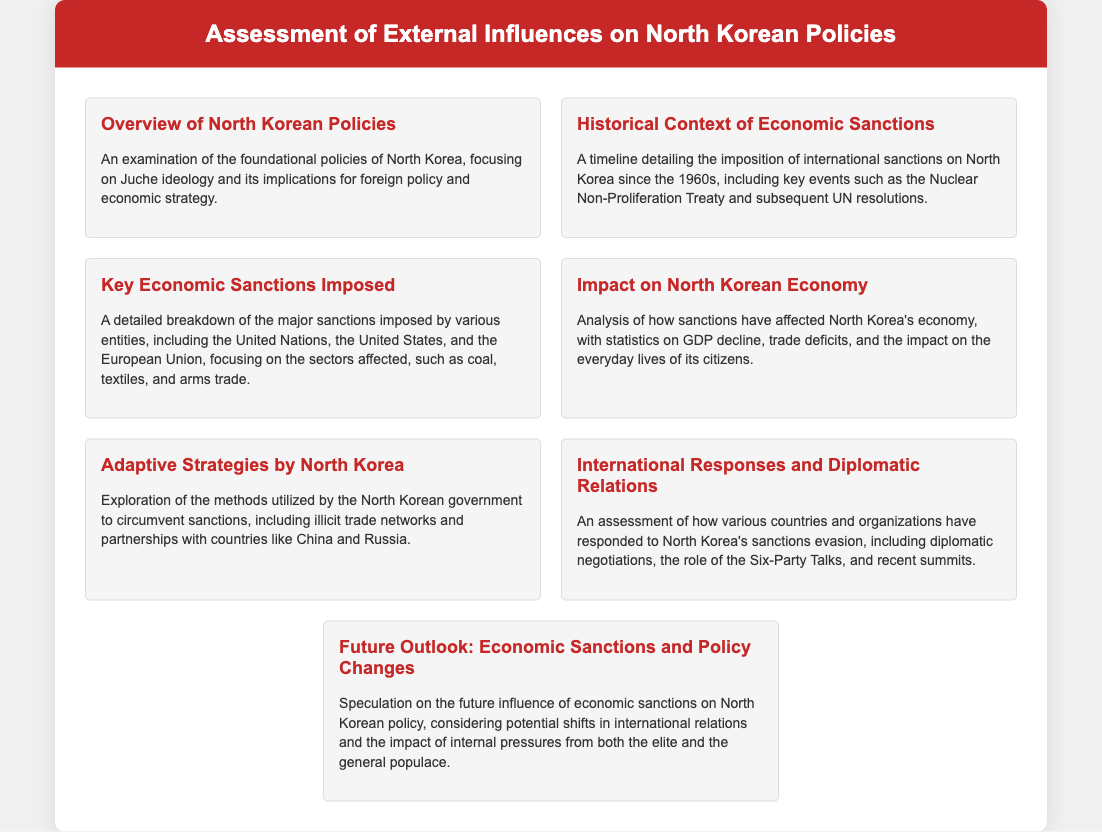What is the foundational ideology of North Korea? The document mentions that the foundational policies of North Korea focus on Juche ideology.
Answer: Juche What key international agreement is mentioned in the historical context of sanctions? The document states that the timeline includes key events such as the Nuclear Non-Proliferation Treaty.
Answer: Nuclear Non-Proliferation Treaty What major sectors are affected by economic sanctions on North Korea? The document specifically lists sectors like coal, textiles, and arms trade as affected by sanctions.
Answer: Coal, textiles, arms trade How has North Korea's GDP been affected according to the analysis? The document discusses the impact of sanctions on North Korea's economy, mentioning statistics on GDP decline.
Answer: GDP decline What country is noted for its partnership with North Korea in circumventing sanctions? The document indicates that North Korea has developed partnerships with countries like China and Russia to circumvent sanctions.
Answer: China, Russia Which diplomatic effort is mentioned in response to North Korea's sanctions evasion? The document refers to the role of the Six-Party Talks as a diplomatic response.
Answer: Six-Party Talks What is speculated about the future influence of economic sanctions? The document mentions considering potential shifts in international relations and internal pressures in the future outlook.
Answer: Internal pressures and international relations How has the everyday lives of citizens been impacted by sanctions? The document addresses the impact of sanctions on the everyday lives of citizens within the analysis of the economy.
Answer: Everyday lives of citizens 